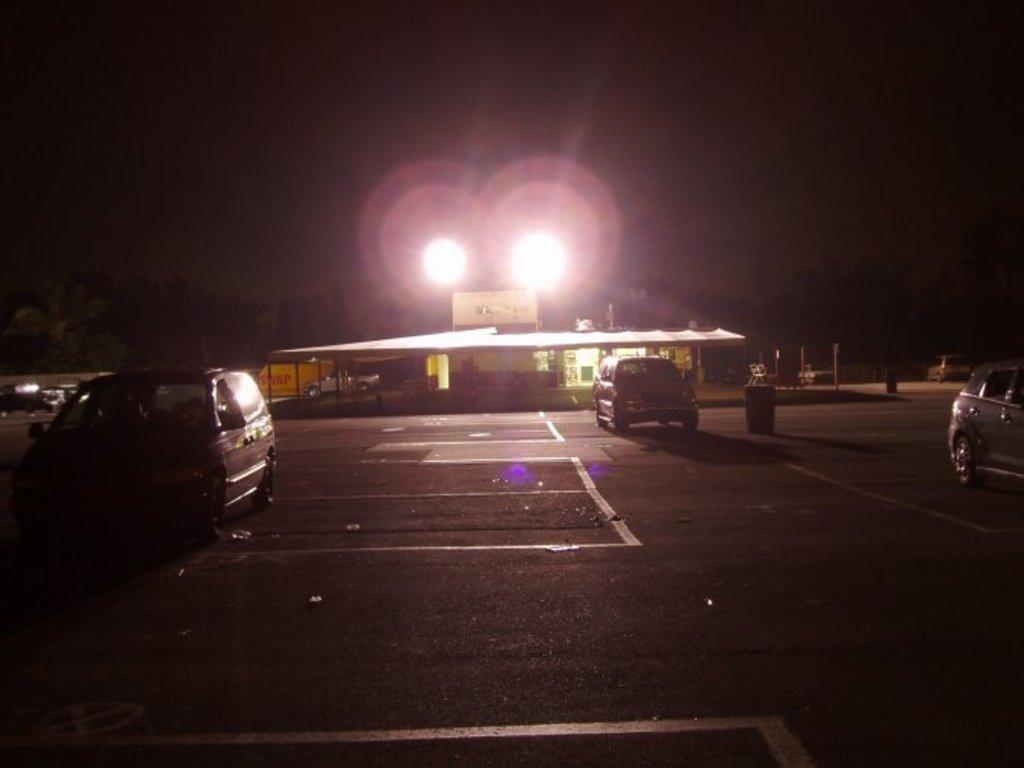What can be seen on the road in the image? There are vehicles on the road in the image. What else is visible in the background of the image? There are lights visible in the background of the image. What type of hill can be seen in the image? There is no hill present in the image. What material is the iron used for in the image? There is no iron present in the image. 